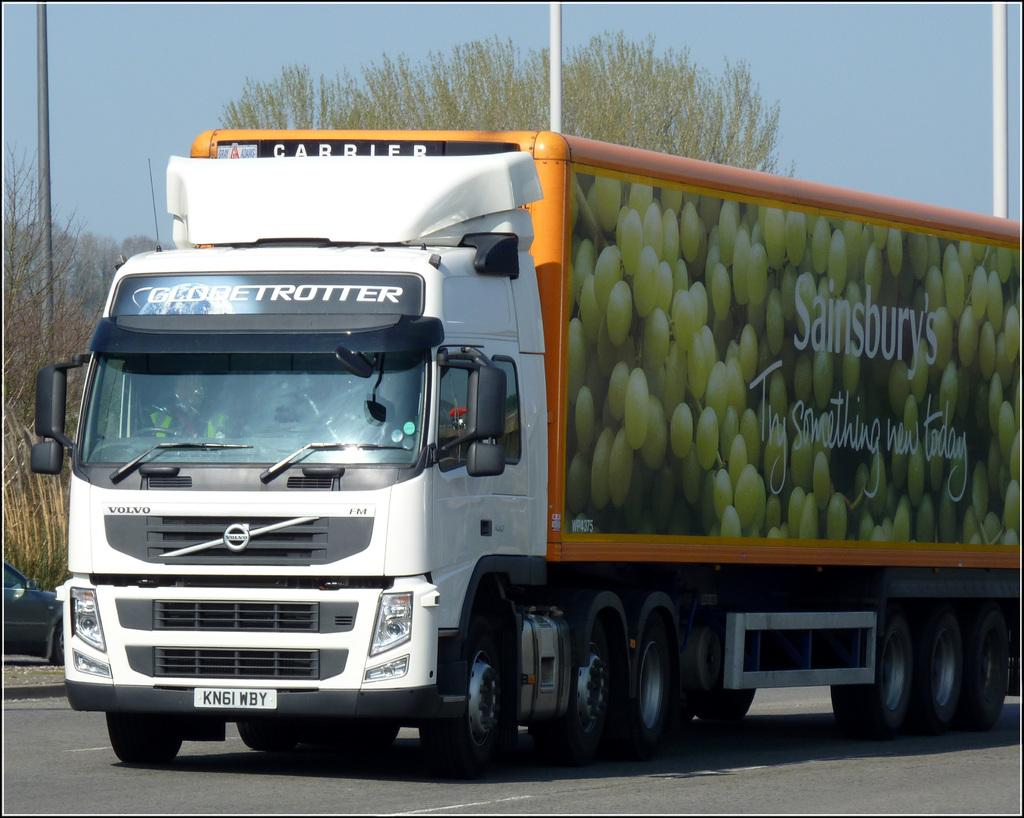What is the main subject of the image? There is a truck in the center of the image. Where is the truck located? The truck is on the road. What can be seen in the background of the image? There are trees, poles, and the sky visible in the background of the image. What type of magic is being performed by the truck in the image? There is no magic being performed by the truck in the image; it is simply a truck on the road. Can you provide any advice on how to control the truck in the image? There is no need to control the truck in the image, as it is a static picture. 